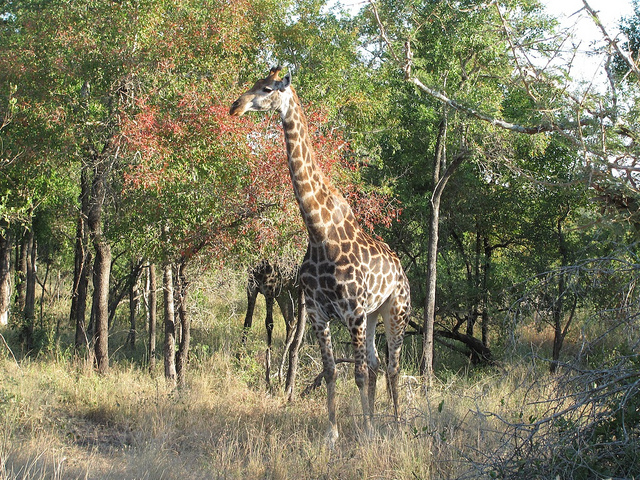Could you tell me more about what giraffes eat? Certainly! Giraffes are browsers and primarily eat leaves, shoots, and twigs from trees and shrubs. Their favorite meals often come from acacia trees, which are abundant in their natural habitat. They have long tongues that allow them to reach vegetation others can't and a specialized digestive system to process the foliage they consume. 